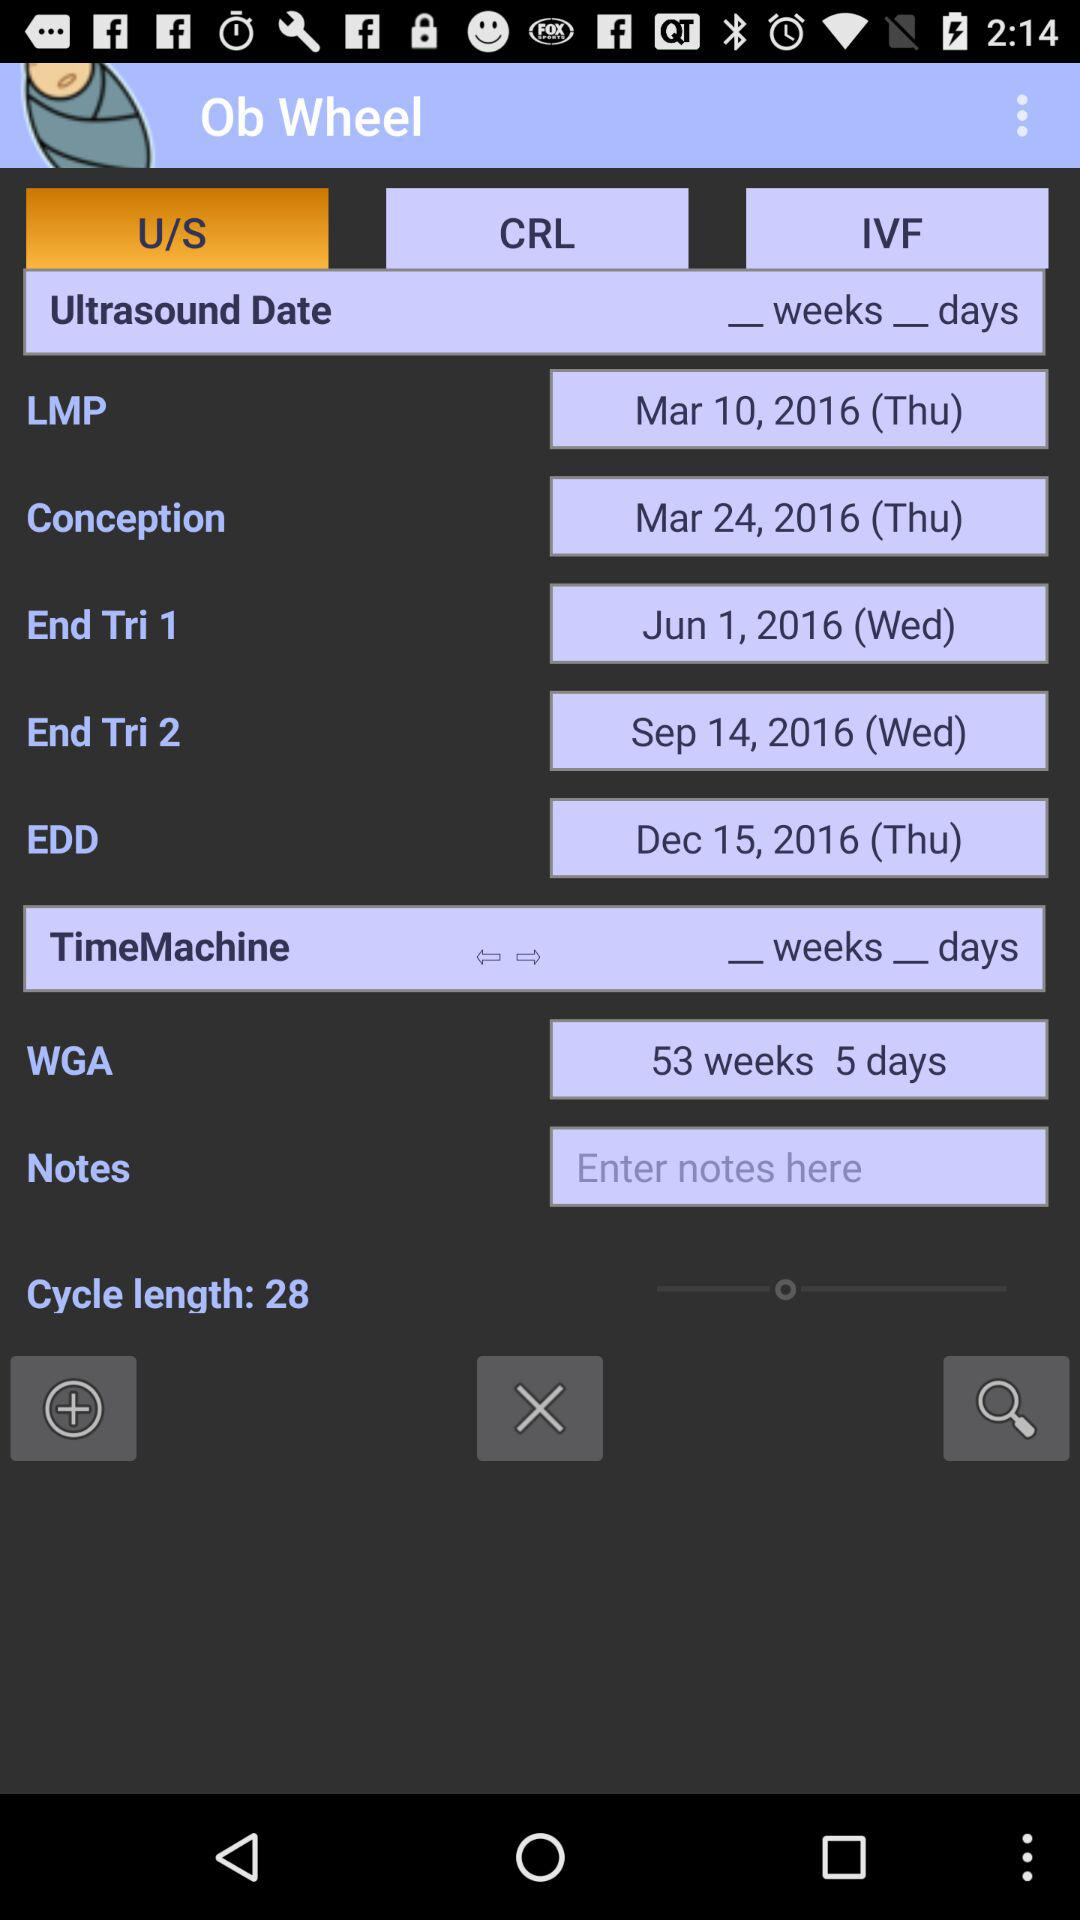What does 'End Tri 1' and 'End Tri 2' mean in this context? 'End Tri 1' and 'End Tri 2' refer to the end of the first and second trimesters of pregnancy, respectively. The first trimester concludes at the end of week 13, and the second at the end of week 26. These milestones are important for tracking fetal development and scheduling necessary medical appointments. 